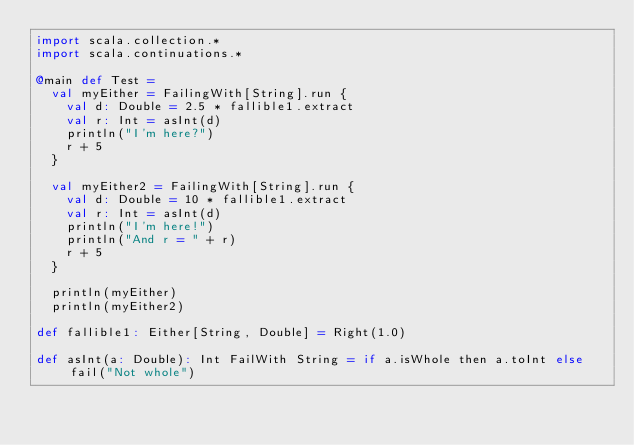Convert code to text. <code><loc_0><loc_0><loc_500><loc_500><_Scala_>import scala.collection.*
import scala.continuations.*

@main def Test =
  val myEither = FailingWith[String].run {
    val d: Double = 2.5 * fallible1.extract
    val r: Int = asInt(d)
    println("I'm here?")
    r + 5
  }

  val myEither2 = FailingWith[String].run {
    val d: Double = 10 * fallible1.extract
    val r: Int = asInt(d)
    println("I'm here!")
    println("And r = " + r)
    r + 5
  }

  println(myEither)
  println(myEither2)

def fallible1: Either[String, Double] = Right(1.0)

def asInt(a: Double): Int FailWith String = if a.isWhole then a.toInt else fail("Not whole")
</code> 